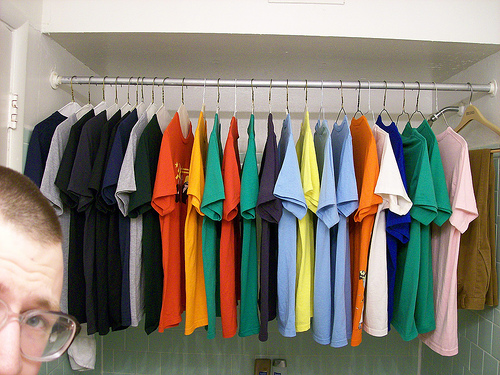<image>
Is there a dress behind the man? Yes. From this viewpoint, the dress is positioned behind the man, with the man partially or fully occluding the dress. 